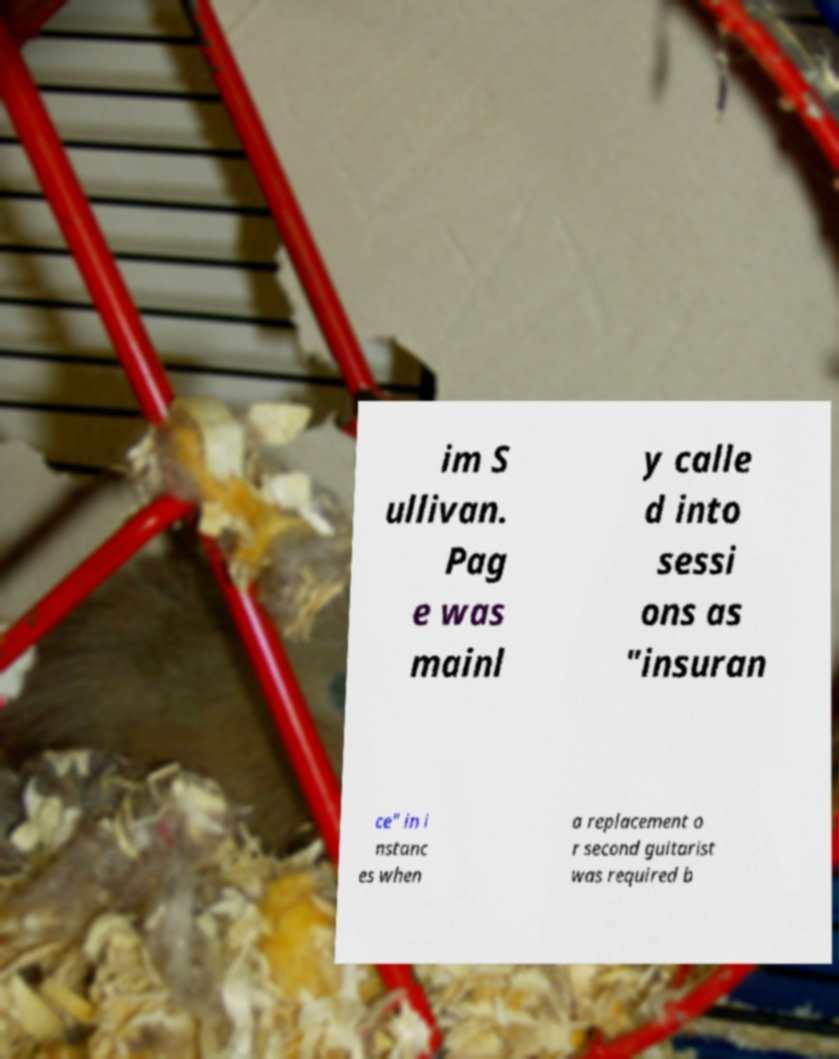There's text embedded in this image that I need extracted. Can you transcribe it verbatim? im S ullivan. Pag e was mainl y calle d into sessi ons as "insuran ce" in i nstanc es when a replacement o r second guitarist was required b 